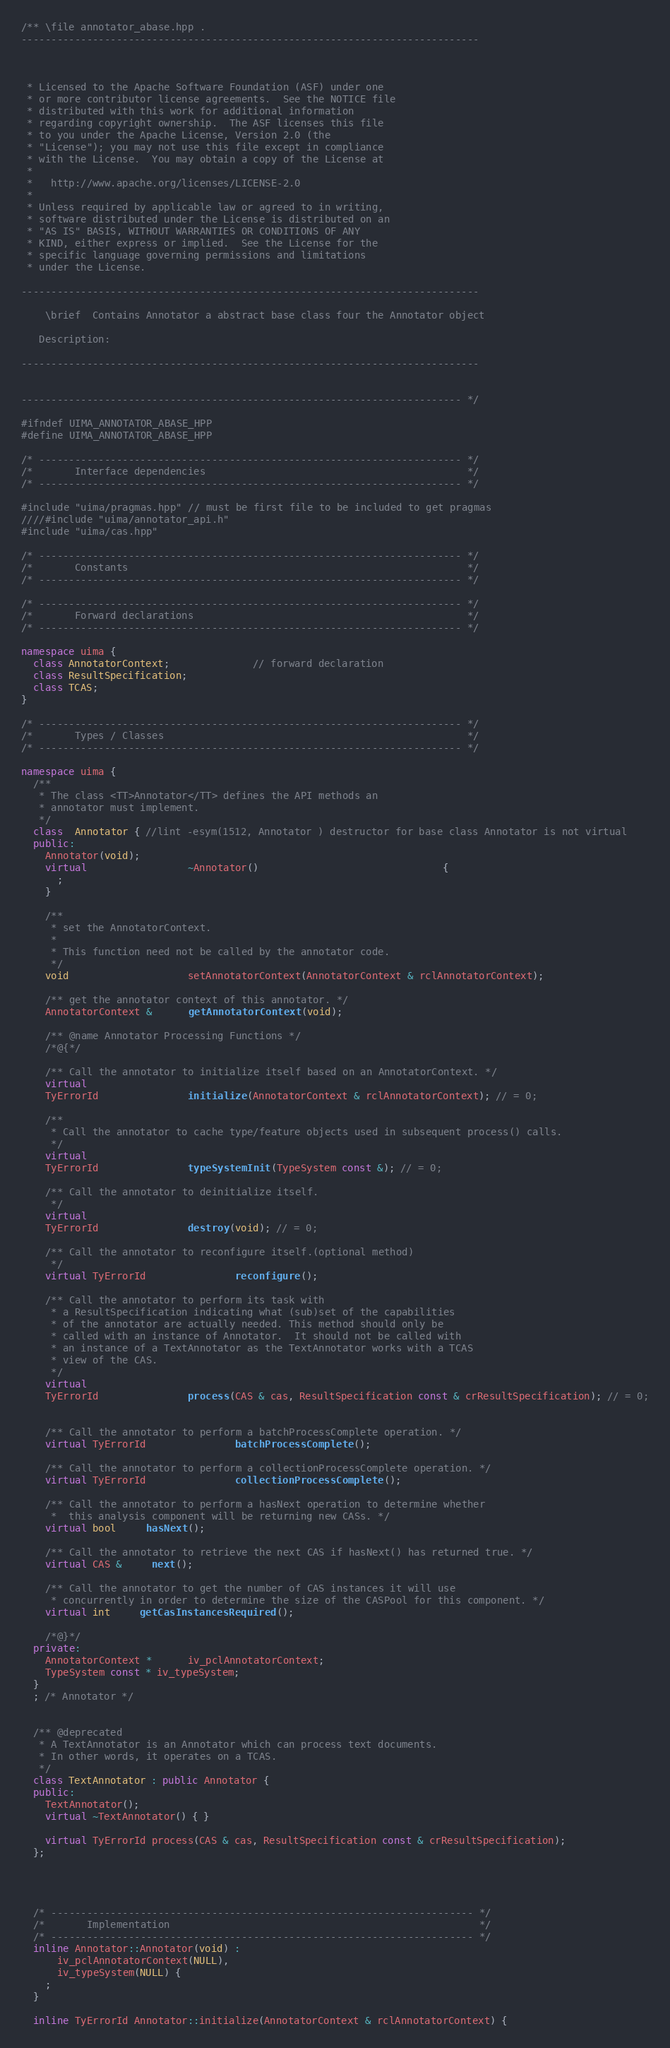Convert code to text. <code><loc_0><loc_0><loc_500><loc_500><_C++_>/** \file annotator_abase.hpp .
-----------------------------------------------------------------------------



 * Licensed to the Apache Software Foundation (ASF) under one
 * or more contributor license agreements.  See the NOTICE file
 * distributed with this work for additional information
 * regarding copyright ownership.  The ASF licenses this file
 * to you under the Apache License, Version 2.0 (the
 * "License"); you may not use this file except in compliance
 * with the License.  You may obtain a copy of the License at
 *
 *   http://www.apache.org/licenses/LICENSE-2.0
 *
 * Unless required by applicable law or agreed to in writing,
 * software distributed under the License is distributed on an
 * "AS IS" BASIS, WITHOUT WARRANTIES OR CONDITIONS OF ANY
 * KIND, either express or implied.  See the License for the
 * specific language governing permissions and limitations
 * under the License.

-----------------------------------------------------------------------------

    \brief  Contains Annotator a abstract base class four the Annotator object

   Description:

-----------------------------------------------------------------------------


-------------------------------------------------------------------------- */

#ifndef UIMA_ANNOTATOR_ABASE_HPP
#define UIMA_ANNOTATOR_ABASE_HPP

/* ----------------------------------------------------------------------- */
/*       Interface dependencies                                            */
/* ----------------------------------------------------------------------- */

#include "uima/pragmas.hpp" // must be first file to be included to get pragmas
////#include "uima/annotator_api.h"
#include "uima/cas.hpp"

/* ----------------------------------------------------------------------- */
/*       Constants                                                         */
/* ----------------------------------------------------------------------- */

/* ----------------------------------------------------------------------- */
/*       Forward declarations                                              */
/* ----------------------------------------------------------------------- */

namespace uima {
  class AnnotatorContext;              // forward declaration
  class ResultSpecification;
  class TCAS;
}

/* ----------------------------------------------------------------------- */
/*       Types / Classes                                                   */
/* ----------------------------------------------------------------------- */

namespace uima {
  /**
   * The class <TT>Annotator</TT> defines the API methods an
   * annotator must implement.
   */
  class  Annotator { //lint -esym(1512, Annotator ) destructor for base class Annotator is not virtual
  public:
    Annotator(void);
    virtual                 ~Annotator()                               {
      ;
    }

    /**
     * set the AnnotatorContext.
     *
     * This function need not be called by the annotator code.
     */
    void                    setAnnotatorContext(AnnotatorContext & rclAnnotatorContext);

    /** get the annotator context of this annotator. */
    AnnotatorContext &      getAnnotatorContext(void);

    /** @name Annotator Processing Functions */
    /*@{*/

    /** Call the annotator to initialize itself based on an AnnotatorContext. */
    virtual
    TyErrorId               initialize(AnnotatorContext & rclAnnotatorContext); // = 0;

    /**
     * Call the annotator to cache type/feature objects used in subsequent process() calls.
     */
    virtual
    TyErrorId               typeSystemInit(TypeSystem const &); // = 0;

    /** Call the annotator to deinitialize itself.
     */
    virtual
    TyErrorId               destroy(void); // = 0;

    /** Call the annotator to reconfigure itself.(optional method)
     */
    virtual TyErrorId               reconfigure();

    /** Call the annotator to perform its task with
     * a ResultSpecification indicating what (sub)set of the capabilities
     * of the annotator are actually needed. This method should only be 
     * called with an instance of Annotator.  It should not be called with
     * an instance of a TextAnnotator as the TextAnnotator works with a TCAS
     * view of the CAS.
     */
    virtual
    TyErrorId               process(CAS & cas, ResultSpecification const & crResultSpecification); // = 0;


    /** Call the annotator to perform a batchProcessComplete operation. */
    virtual TyErrorId               batchProcessComplete();

    /** Call the annotator to perform a collectionProcessComplete operation. */
    virtual TyErrorId               collectionProcessComplete();

    /** Call the annotator to perform a hasNext operation to determine whether
     *  this analysis component will be returning new CASs. */
    virtual bool     hasNext();

    /** Call the annotator to retrieve the next CAS if hasNext() has returned true. */
    virtual CAS &     next();

    /** Call the annotator to get the number of CAS instances it will use
     * concurrently in order to determine the size of the CASPool for this component. */
    virtual int     getCasInstancesRequired();

    /*@}*/
  private:
    AnnotatorContext *      iv_pclAnnotatorContext;
    TypeSystem const * iv_typeSystem;
  }
  ; /* Annotator */


  /** @deprecated
   * A TextAnnotator is an Annotator which can process text documents. 
   * In other words, it operates on a TCAS.
   */
  class TextAnnotator : public Annotator {
  public:
    TextAnnotator();
    virtual ~TextAnnotator() { }

    virtual TyErrorId process(CAS & cas, ResultSpecification const & crResultSpecification);
  };




  /* ----------------------------------------------------------------------- */
  /*       Implementation                                                    */
  /* ----------------------------------------------------------------------- */
  inline Annotator::Annotator(void) :
      iv_pclAnnotatorContext(NULL),
      iv_typeSystem(NULL) {
    ;
  }

  inline TyErrorId Annotator::initialize(AnnotatorContext & rclAnnotatorContext) {</code> 